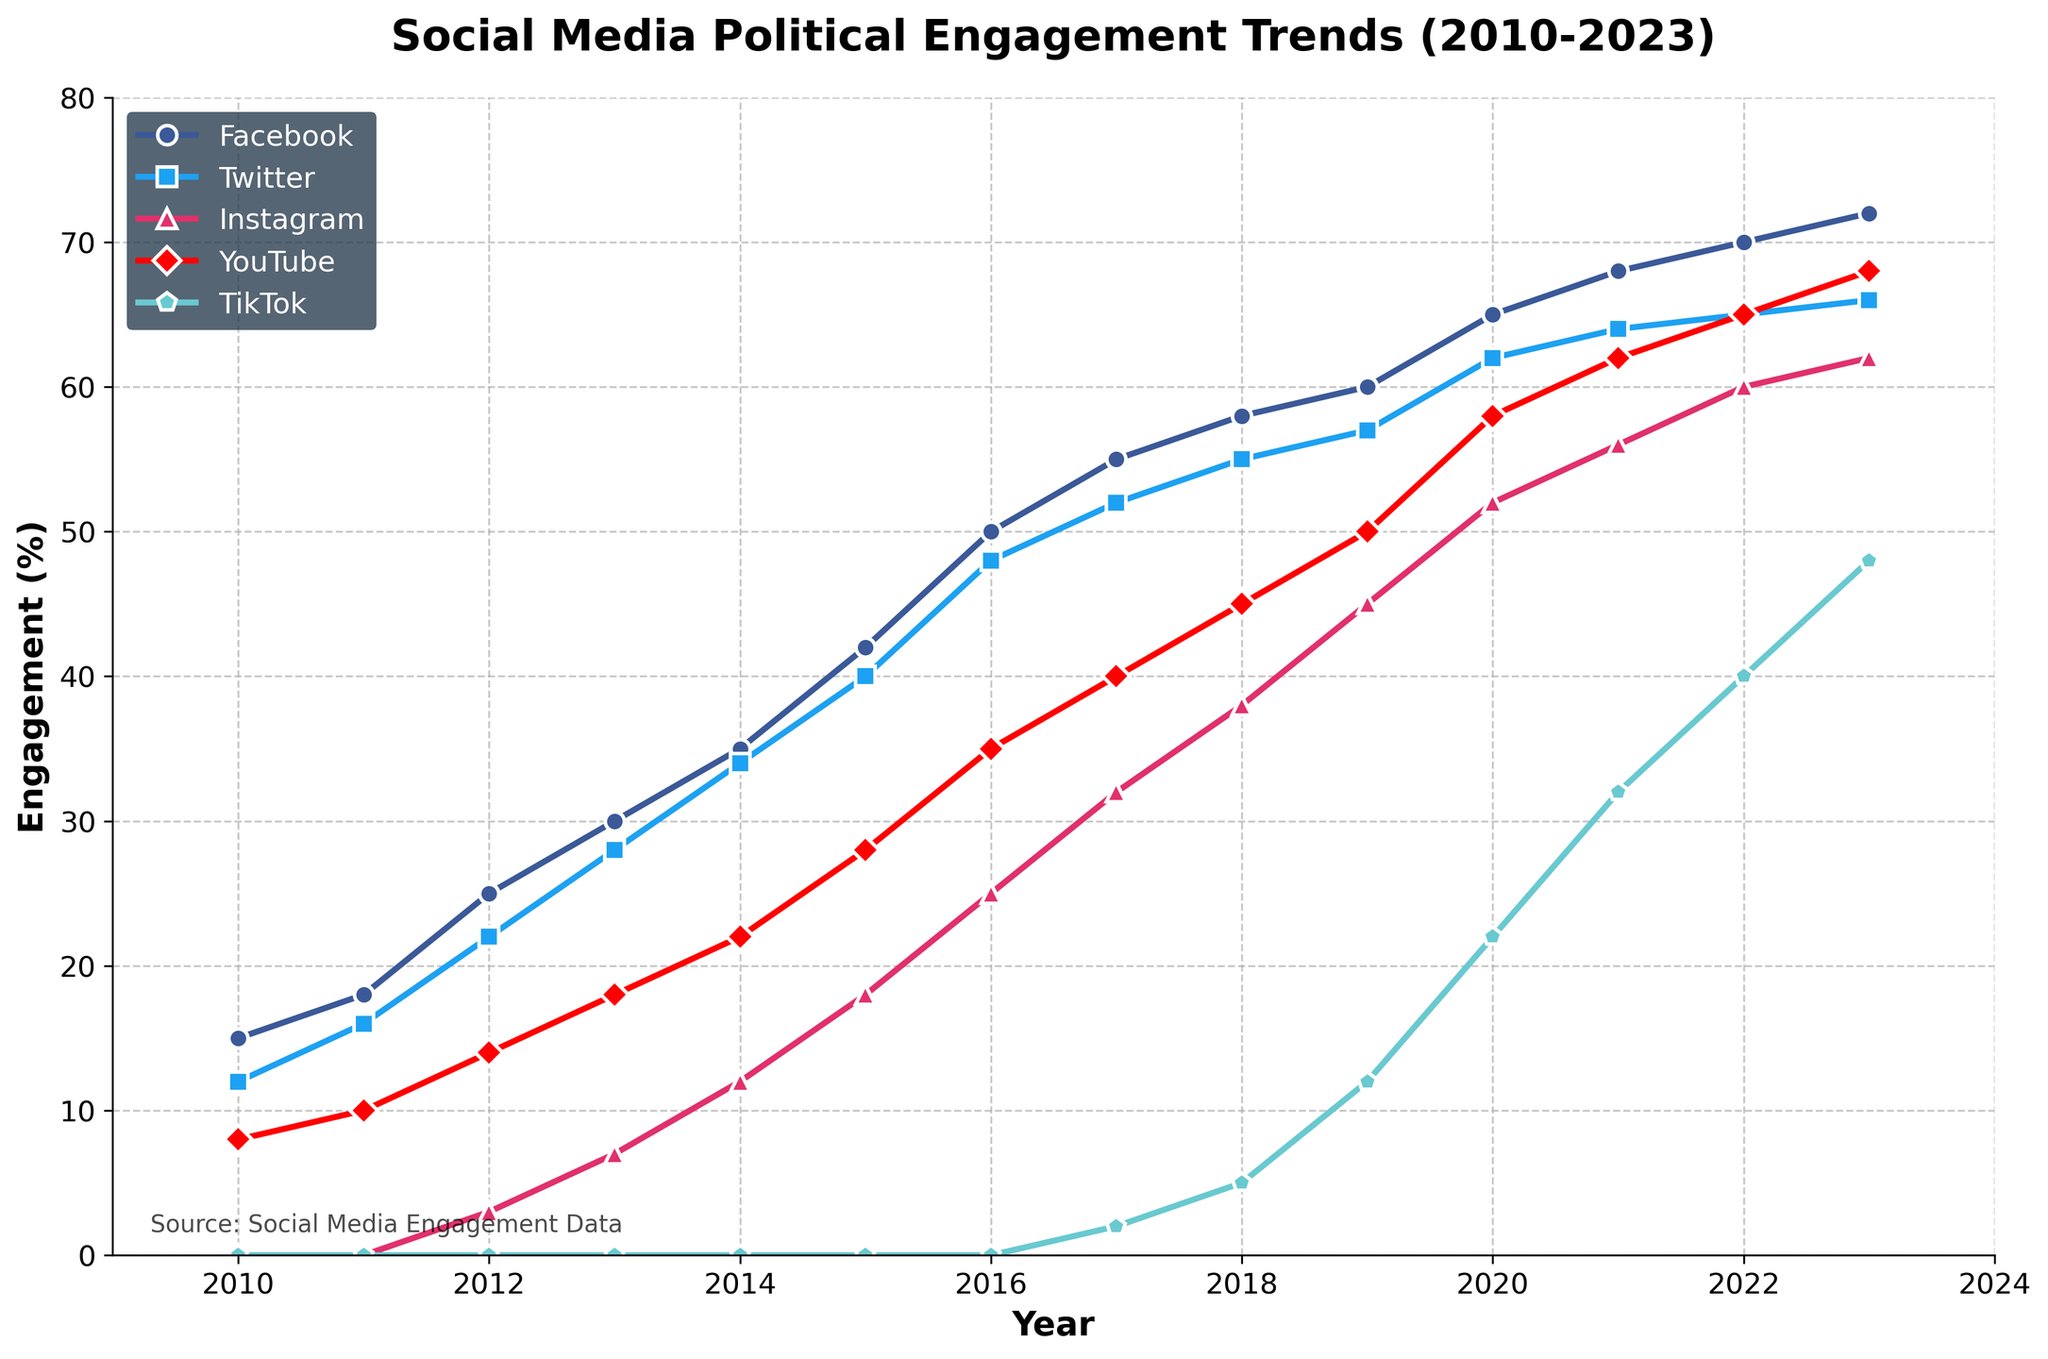What platform experienced the highest increase in engagement from 2010 to 2023? To determine the platform with the highest increase, we need to subtract the 2010 engagement percentage from the 2023 engagement percentage for each platform. By observing the data, we see:
- Facebook: 72 - 15 = 57
- Twitter: 66 - 12 = 54
- Instagram: 62 - 0 = 62
- YouTube: 68 - 8 = 60
- TikTok: 48 - 0 = 48
Thus, Instagram has the highest increase in engagement, with a 62 percent increase.
Answer: Instagram Which platform had the lowest engagement in 2017? By examining the engagement percentages for 2017, we observe: 
- Facebook: 55%
- Twitter: 52%
- Instagram: 32%
- YouTube: 40%
- TikTok: 2%
TikTok had the lowest engagement at 2%.
Answer: TikTok Between 2016 and 2020, which platform saw the largest percentage change and what was it? Calculating the percentage change for each platform between 2016 and 2020:
- Facebook: ((65 - 50)/50) * 100 = 30%
- Twitter: ((62 - 48)/48) * 100 = 29.17%
- Instagram: ((52 - 25)/25) * 100 = 108%
- YouTube: ((58 - 35)/35) * 100 = 65.7%
- TikTok: ((22 - 0)/0) * 100 = Not applicable (started from zero)
Instagram saw the largest percentage change with 108%.
Answer: Instagram, 108% Which two platforms had almost similar engagement levels in 2023? Checking the engagement percentages for 2023:
- Facebook: 72%
- Twitter: 66%
- Instagram: 62%
- YouTube: 68%
- TikTok: 48%
Twitter and YouTube had almost similar engagement levels, 66% and 68% respectively.
Answer: Twitter and YouTube What was the average engagement across all platforms in 2015? Summing the engagement percentages in 2015 and dividing by the number of platforms:
(42 + 40 + 18 + 28 + 0) / 5 = 25.6
Answer: 25.6 In which year did Instagram's engagement surpass YouTube's engagement? Comparing the engagement values year by year:
- 2010 to 2016: Instagram is lower than YouTube
- 2017: Instagram (32) and YouTube (40), still lower
- 2018: Instagram (38) and YouTube (45), still lower
- 2019: Instagram (45) and YouTube (50), still lower
- 2020: Instagram (52) surpasses YouTube (50)
So, in 2020, Instagram's engagement surpassed YouTube's.
Answer: 2020 Calculate the total engagement for all platforms combined in the year 2023. Adding the engagement percentages for each platform in 2023:
72 + 66 + 62 + 68 + 48 = 316
Answer: 316 